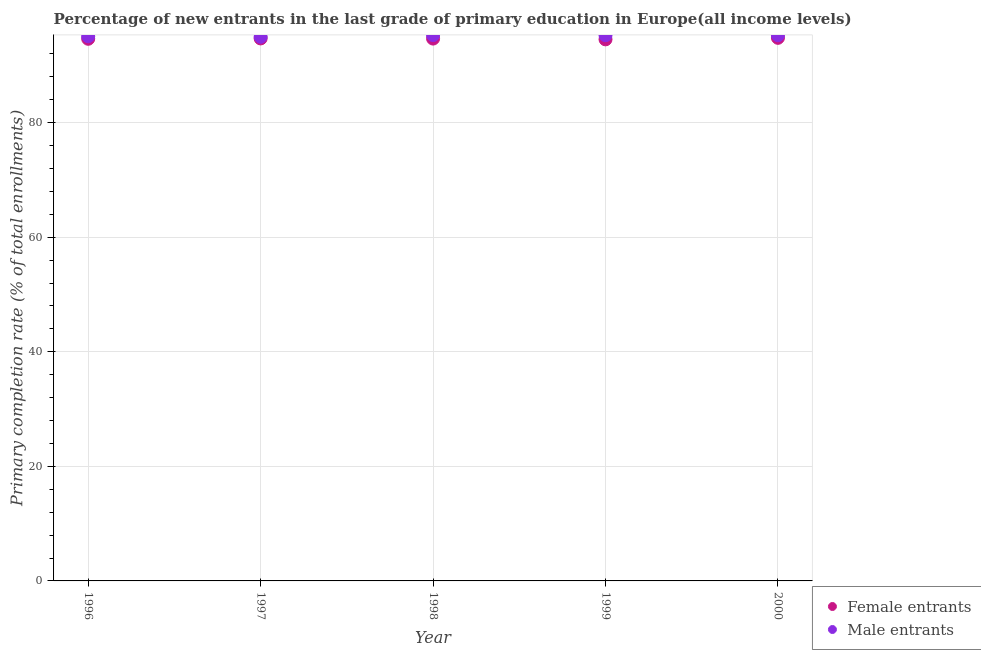How many different coloured dotlines are there?
Your answer should be compact. 2. What is the primary completion rate of male entrants in 1999?
Make the answer very short. 95.27. Across all years, what is the maximum primary completion rate of male entrants?
Provide a short and direct response. 95.29. Across all years, what is the minimum primary completion rate of female entrants?
Your answer should be compact. 94.55. In which year was the primary completion rate of male entrants minimum?
Your answer should be compact. 1997. What is the total primary completion rate of male entrants in the graph?
Your response must be concise. 475.89. What is the difference between the primary completion rate of male entrants in 1996 and that in 2000?
Make the answer very short. -0.18. What is the difference between the primary completion rate of male entrants in 1999 and the primary completion rate of female entrants in 2000?
Provide a short and direct response. 0.46. What is the average primary completion rate of female entrants per year?
Provide a succinct answer. 94.68. In the year 1996, what is the difference between the primary completion rate of male entrants and primary completion rate of female entrants?
Ensure brevity in your answer.  0.44. What is the ratio of the primary completion rate of female entrants in 1997 to that in 1999?
Your response must be concise. 1. What is the difference between the highest and the second highest primary completion rate of female entrants?
Provide a short and direct response. 0.1. What is the difference between the highest and the lowest primary completion rate of female entrants?
Provide a short and direct response. 0.26. Is the sum of the primary completion rate of female entrants in 1996 and 1999 greater than the maximum primary completion rate of male entrants across all years?
Provide a short and direct response. Yes. Does the primary completion rate of male entrants monotonically increase over the years?
Provide a succinct answer. No. Is the primary completion rate of female entrants strictly greater than the primary completion rate of male entrants over the years?
Give a very brief answer. No. What is the difference between two consecutive major ticks on the Y-axis?
Your answer should be very brief. 20. Are the values on the major ticks of Y-axis written in scientific E-notation?
Your response must be concise. No. Does the graph contain any zero values?
Your response must be concise. No. Does the graph contain grids?
Offer a very short reply. Yes. Where does the legend appear in the graph?
Your response must be concise. Bottom right. How many legend labels are there?
Offer a terse response. 2. What is the title of the graph?
Your answer should be very brief. Percentage of new entrants in the last grade of primary education in Europe(all income levels). What is the label or title of the X-axis?
Your response must be concise. Year. What is the label or title of the Y-axis?
Your answer should be compact. Primary completion rate (% of total enrollments). What is the Primary completion rate (% of total enrollments) of Female entrants in 1996?
Offer a very short reply. 94.64. What is the Primary completion rate (% of total enrollments) of Male entrants in 1996?
Offer a very short reply. 95.08. What is the Primary completion rate (% of total enrollments) in Female entrants in 1997?
Provide a short and direct response. 94.71. What is the Primary completion rate (% of total enrollments) of Male entrants in 1997?
Your response must be concise. 94.99. What is the Primary completion rate (% of total enrollments) in Female entrants in 1998?
Offer a very short reply. 94.68. What is the Primary completion rate (% of total enrollments) in Male entrants in 1998?
Offer a terse response. 95.29. What is the Primary completion rate (% of total enrollments) of Female entrants in 1999?
Make the answer very short. 94.55. What is the Primary completion rate (% of total enrollments) of Male entrants in 1999?
Provide a succinct answer. 95.27. What is the Primary completion rate (% of total enrollments) of Female entrants in 2000?
Your answer should be compact. 94.81. What is the Primary completion rate (% of total enrollments) of Male entrants in 2000?
Give a very brief answer. 95.26. Across all years, what is the maximum Primary completion rate (% of total enrollments) of Female entrants?
Your response must be concise. 94.81. Across all years, what is the maximum Primary completion rate (% of total enrollments) in Male entrants?
Make the answer very short. 95.29. Across all years, what is the minimum Primary completion rate (% of total enrollments) in Female entrants?
Your answer should be compact. 94.55. Across all years, what is the minimum Primary completion rate (% of total enrollments) in Male entrants?
Ensure brevity in your answer.  94.99. What is the total Primary completion rate (% of total enrollments) of Female entrants in the graph?
Ensure brevity in your answer.  473.38. What is the total Primary completion rate (% of total enrollments) of Male entrants in the graph?
Keep it short and to the point. 475.89. What is the difference between the Primary completion rate (% of total enrollments) of Female entrants in 1996 and that in 1997?
Provide a short and direct response. -0.06. What is the difference between the Primary completion rate (% of total enrollments) in Male entrants in 1996 and that in 1997?
Your answer should be very brief. 0.09. What is the difference between the Primary completion rate (% of total enrollments) of Female entrants in 1996 and that in 1998?
Your answer should be compact. -0.03. What is the difference between the Primary completion rate (% of total enrollments) of Male entrants in 1996 and that in 1998?
Keep it short and to the point. -0.21. What is the difference between the Primary completion rate (% of total enrollments) of Female entrants in 1996 and that in 1999?
Offer a terse response. 0.1. What is the difference between the Primary completion rate (% of total enrollments) in Male entrants in 1996 and that in 1999?
Keep it short and to the point. -0.18. What is the difference between the Primary completion rate (% of total enrollments) in Female entrants in 1996 and that in 2000?
Ensure brevity in your answer.  -0.17. What is the difference between the Primary completion rate (% of total enrollments) in Male entrants in 1996 and that in 2000?
Provide a succinct answer. -0.18. What is the difference between the Primary completion rate (% of total enrollments) in Female entrants in 1997 and that in 1998?
Provide a short and direct response. 0.03. What is the difference between the Primary completion rate (% of total enrollments) in Male entrants in 1997 and that in 1998?
Keep it short and to the point. -0.3. What is the difference between the Primary completion rate (% of total enrollments) of Female entrants in 1997 and that in 1999?
Your answer should be compact. 0.16. What is the difference between the Primary completion rate (% of total enrollments) in Male entrants in 1997 and that in 1999?
Offer a terse response. -0.28. What is the difference between the Primary completion rate (% of total enrollments) in Female entrants in 1997 and that in 2000?
Offer a very short reply. -0.1. What is the difference between the Primary completion rate (% of total enrollments) of Male entrants in 1997 and that in 2000?
Provide a succinct answer. -0.27. What is the difference between the Primary completion rate (% of total enrollments) of Female entrants in 1998 and that in 1999?
Give a very brief answer. 0.13. What is the difference between the Primary completion rate (% of total enrollments) in Male entrants in 1998 and that in 1999?
Provide a succinct answer. 0.02. What is the difference between the Primary completion rate (% of total enrollments) of Female entrants in 1998 and that in 2000?
Offer a terse response. -0.13. What is the difference between the Primary completion rate (% of total enrollments) of Male entrants in 1998 and that in 2000?
Your answer should be compact. 0.03. What is the difference between the Primary completion rate (% of total enrollments) in Female entrants in 1999 and that in 2000?
Ensure brevity in your answer.  -0.26. What is the difference between the Primary completion rate (% of total enrollments) of Male entrants in 1999 and that in 2000?
Offer a terse response. 0. What is the difference between the Primary completion rate (% of total enrollments) of Female entrants in 1996 and the Primary completion rate (% of total enrollments) of Male entrants in 1997?
Offer a terse response. -0.35. What is the difference between the Primary completion rate (% of total enrollments) of Female entrants in 1996 and the Primary completion rate (% of total enrollments) of Male entrants in 1998?
Provide a succinct answer. -0.65. What is the difference between the Primary completion rate (% of total enrollments) in Female entrants in 1996 and the Primary completion rate (% of total enrollments) in Male entrants in 1999?
Provide a short and direct response. -0.62. What is the difference between the Primary completion rate (% of total enrollments) in Female entrants in 1996 and the Primary completion rate (% of total enrollments) in Male entrants in 2000?
Your answer should be very brief. -0.62. What is the difference between the Primary completion rate (% of total enrollments) in Female entrants in 1997 and the Primary completion rate (% of total enrollments) in Male entrants in 1998?
Your answer should be compact. -0.58. What is the difference between the Primary completion rate (% of total enrollments) in Female entrants in 1997 and the Primary completion rate (% of total enrollments) in Male entrants in 1999?
Provide a succinct answer. -0.56. What is the difference between the Primary completion rate (% of total enrollments) in Female entrants in 1997 and the Primary completion rate (% of total enrollments) in Male entrants in 2000?
Offer a terse response. -0.56. What is the difference between the Primary completion rate (% of total enrollments) of Female entrants in 1998 and the Primary completion rate (% of total enrollments) of Male entrants in 1999?
Make the answer very short. -0.59. What is the difference between the Primary completion rate (% of total enrollments) of Female entrants in 1998 and the Primary completion rate (% of total enrollments) of Male entrants in 2000?
Your answer should be very brief. -0.58. What is the difference between the Primary completion rate (% of total enrollments) of Female entrants in 1999 and the Primary completion rate (% of total enrollments) of Male entrants in 2000?
Offer a very short reply. -0.72. What is the average Primary completion rate (% of total enrollments) in Female entrants per year?
Provide a succinct answer. 94.68. What is the average Primary completion rate (% of total enrollments) in Male entrants per year?
Your response must be concise. 95.18. In the year 1996, what is the difference between the Primary completion rate (% of total enrollments) in Female entrants and Primary completion rate (% of total enrollments) in Male entrants?
Ensure brevity in your answer.  -0.44. In the year 1997, what is the difference between the Primary completion rate (% of total enrollments) of Female entrants and Primary completion rate (% of total enrollments) of Male entrants?
Your response must be concise. -0.28. In the year 1998, what is the difference between the Primary completion rate (% of total enrollments) of Female entrants and Primary completion rate (% of total enrollments) of Male entrants?
Offer a very short reply. -0.61. In the year 1999, what is the difference between the Primary completion rate (% of total enrollments) in Female entrants and Primary completion rate (% of total enrollments) in Male entrants?
Your response must be concise. -0.72. In the year 2000, what is the difference between the Primary completion rate (% of total enrollments) of Female entrants and Primary completion rate (% of total enrollments) of Male entrants?
Your response must be concise. -0.45. What is the ratio of the Primary completion rate (% of total enrollments) in Female entrants in 1996 to that in 1997?
Ensure brevity in your answer.  1. What is the ratio of the Primary completion rate (% of total enrollments) in Female entrants in 1996 to that in 1998?
Offer a very short reply. 1. What is the ratio of the Primary completion rate (% of total enrollments) in Male entrants in 1996 to that in 1998?
Ensure brevity in your answer.  1. What is the ratio of the Primary completion rate (% of total enrollments) in Female entrants in 1996 to that in 1999?
Ensure brevity in your answer.  1. What is the ratio of the Primary completion rate (% of total enrollments) of Female entrants in 1996 to that in 2000?
Your answer should be compact. 1. What is the ratio of the Primary completion rate (% of total enrollments) of Male entrants in 1996 to that in 2000?
Your response must be concise. 1. What is the ratio of the Primary completion rate (% of total enrollments) in Female entrants in 1997 to that in 1998?
Provide a short and direct response. 1. What is the ratio of the Primary completion rate (% of total enrollments) in Male entrants in 1997 to that in 1999?
Provide a short and direct response. 1. What is the ratio of the Primary completion rate (% of total enrollments) of Male entrants in 1997 to that in 2000?
Offer a terse response. 1. What is the ratio of the Primary completion rate (% of total enrollments) in Female entrants in 1999 to that in 2000?
Ensure brevity in your answer.  1. What is the difference between the highest and the second highest Primary completion rate (% of total enrollments) in Female entrants?
Make the answer very short. 0.1. What is the difference between the highest and the second highest Primary completion rate (% of total enrollments) in Male entrants?
Your answer should be compact. 0.02. What is the difference between the highest and the lowest Primary completion rate (% of total enrollments) in Female entrants?
Provide a short and direct response. 0.26. What is the difference between the highest and the lowest Primary completion rate (% of total enrollments) in Male entrants?
Offer a very short reply. 0.3. 